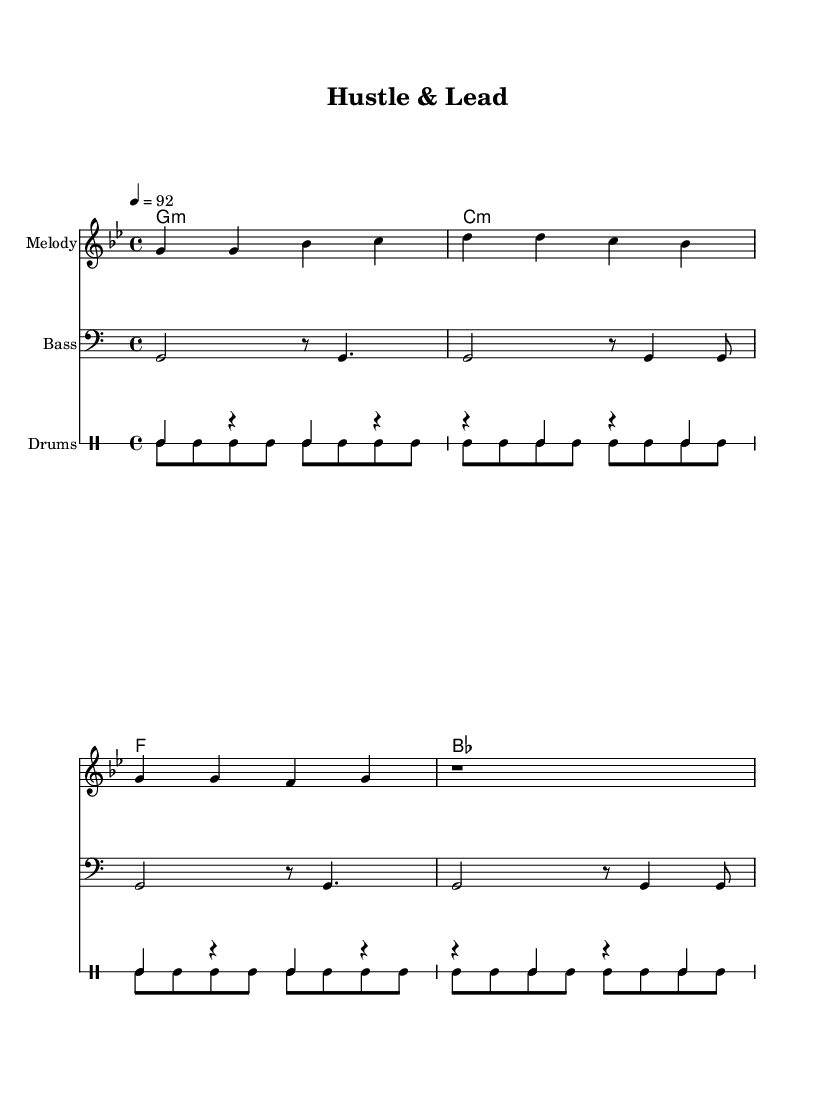What is the key signature of this music? The key signature indicated in the global settings is G minor, which has two flats (B flat and E flat).
Answer: G minor What is the time signature of this piece? The time signature shown in the global settings is 4/4, indicating four beats per measure.
Answer: 4/4 What is the tempo of the music? The tempo specified in the global section is 92 beats per minute, which sets the speed of the piece.
Answer: 92 What chord appears most frequently in the harmonies? By examining the chord progression in the harmonies, the G minor chord is the first one, and it is repeated throughout the piece.
Answer: G minor Why is the bass clef used in this music? The bass clef is used because it typically denotes lower pitches, which correspond to the bass part, indicating support for the harmony and rhythm.
Answer: Lower pitches What is the mood conveyed by the lyrics? The lyrics, referencing vision and ambition, suggest a motivational and positive atmosphere, aligning with themes of leadership and entrepreneurship.
Answer: Motivational 